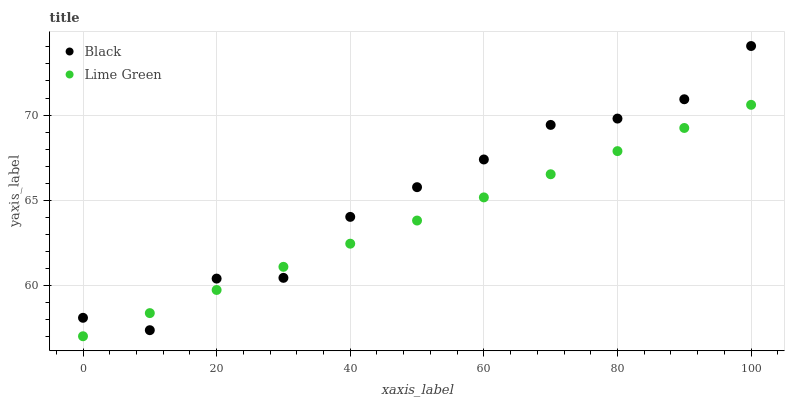Does Lime Green have the minimum area under the curve?
Answer yes or no. Yes. Does Black have the maximum area under the curve?
Answer yes or no. Yes. Does Black have the minimum area under the curve?
Answer yes or no. No. Is Lime Green the smoothest?
Answer yes or no. Yes. Is Black the roughest?
Answer yes or no. Yes. Is Black the smoothest?
Answer yes or no. No. Does Lime Green have the lowest value?
Answer yes or no. Yes. Does Black have the lowest value?
Answer yes or no. No. Does Black have the highest value?
Answer yes or no. Yes. Does Lime Green intersect Black?
Answer yes or no. Yes. Is Lime Green less than Black?
Answer yes or no. No. Is Lime Green greater than Black?
Answer yes or no. No. 